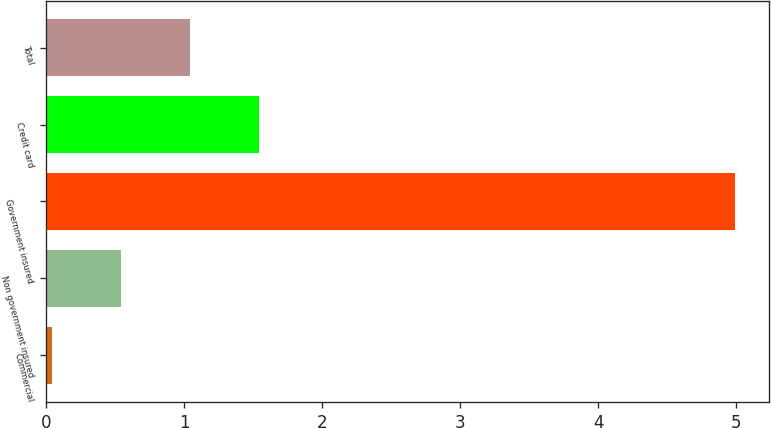<chart> <loc_0><loc_0><loc_500><loc_500><bar_chart><fcel>Commercial<fcel>Non government insured<fcel>Government insured<fcel>Credit card<fcel>Total<nl><fcel>0.04<fcel>0.54<fcel>4.99<fcel>1.54<fcel>1.04<nl></chart> 